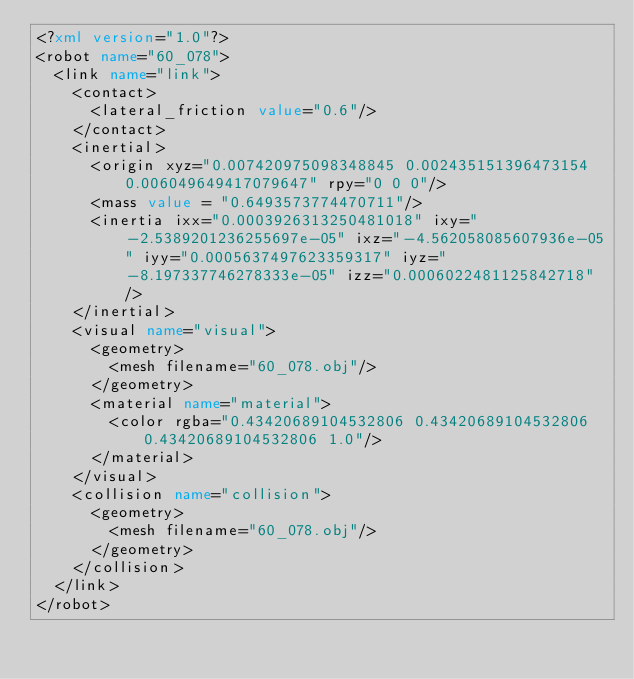<code> <loc_0><loc_0><loc_500><loc_500><_XML_><?xml version="1.0"?>
<robot name="60_078">
  <link name="link">
    <contact>
      <lateral_friction value="0.6"/>
    </contact>
    <inertial>
      <origin xyz="0.007420975098348845 0.002435151396473154 0.006049649417079647" rpy="0 0 0"/>
      <mass value = "0.6493573774470711"/>
      <inertia ixx="0.0003926313250481018" ixy="-2.5389201236255697e-05" ixz="-4.562058085607936e-05" iyy="0.0005637497623359317" iyz="-8.197337746278333e-05" izz="0.0006022481125842718" />
    </inertial>
    <visual name="visual">
      <geometry>
        <mesh filename="60_078.obj"/>
      </geometry>
      <material name="material">
        <color rgba="0.43420689104532806 0.43420689104532806 0.43420689104532806 1.0"/>
      </material>
    </visual>
    <collision name="collision">
      <geometry>
        <mesh filename="60_078.obj"/>
      </geometry>
    </collision>
  </link>
</robot>
</code> 